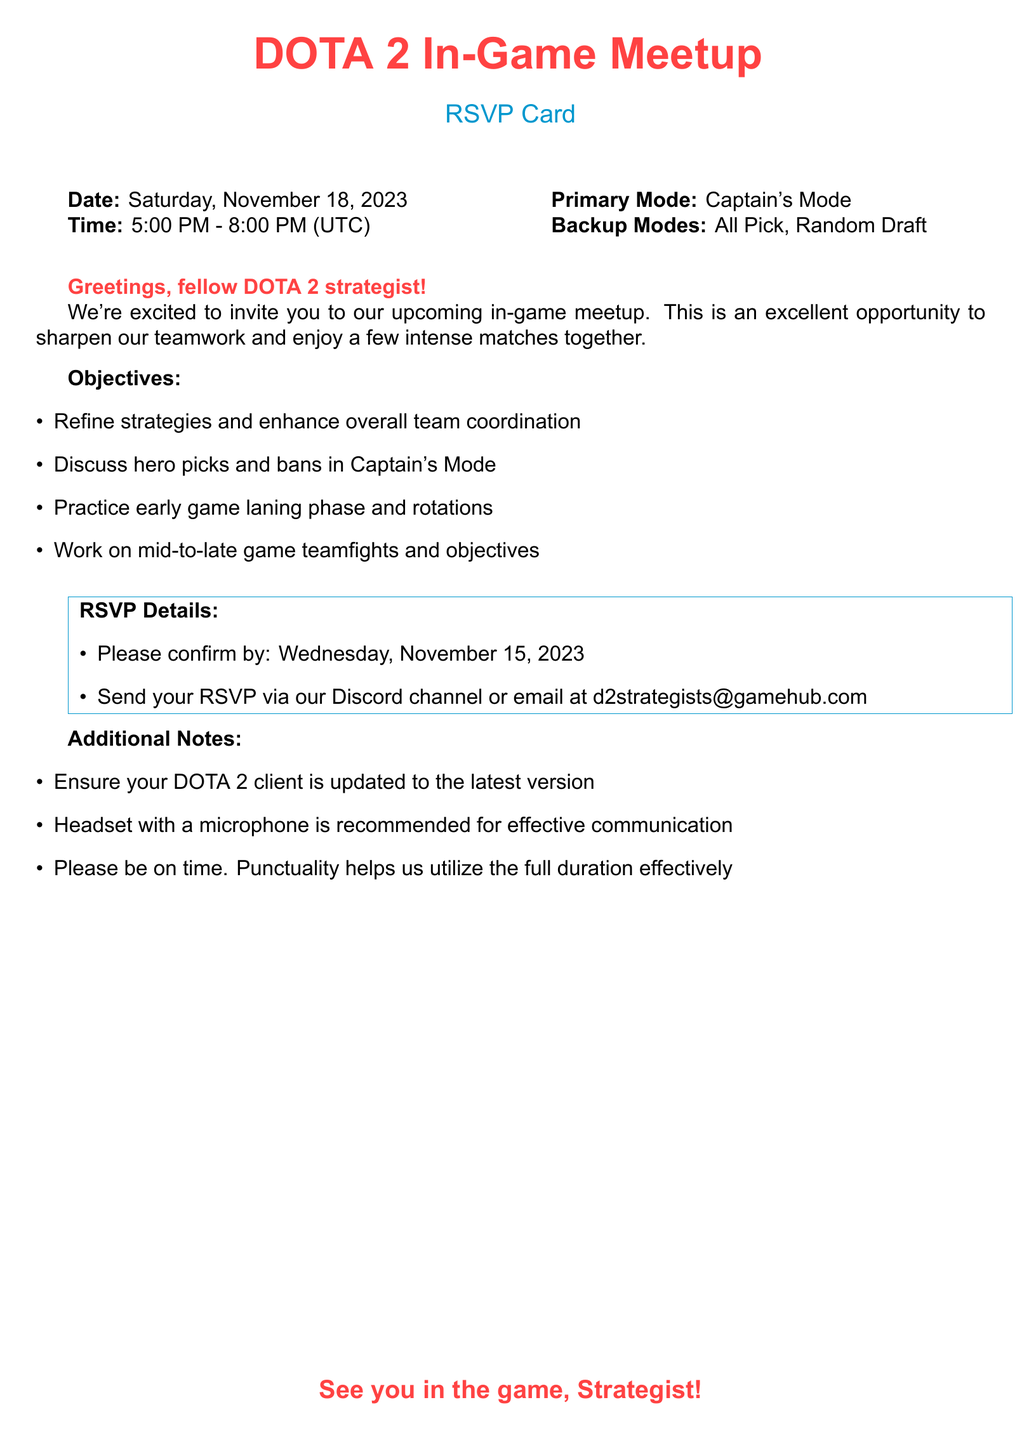What is the date of the meetup? The document states that the date of the meetup is Saturday, November 18, 2023.
Answer: Saturday, November 18, 2023 What time does the meetup start? The document mentions that the meetup starts at 5:00 PM (UTC).
Answer: 5:00 PM What is the primary mode for the meetup? According to the document, the primary mode for the meetup is Captain's Mode.
Answer: Captain's Mode By when should participants confirm their attendance? The document specifies that participants should confirm by Wednesday, November 15, 2023.
Answer: Wednesday, November 15, 2023 What are the backup modes listed in the document? The document lists All Pick and Random Draft as backup modes.
Answer: All Pick, Random Draft Why is punctuality emphasized in the document? The document indicates that punctuality helps utilize the full duration of the meetup effectively.
Answer: To utilize the full duration effectively What should players ensure regarding their DOTA 2 client? The document advises that players should ensure their DOTA 2 client is updated to the latest version.
Answer: Updated to the latest version What means of communication is recommended for the meetup? The document recommends using a headset with a microphone for effective communication.
Answer: Headset with a microphone 